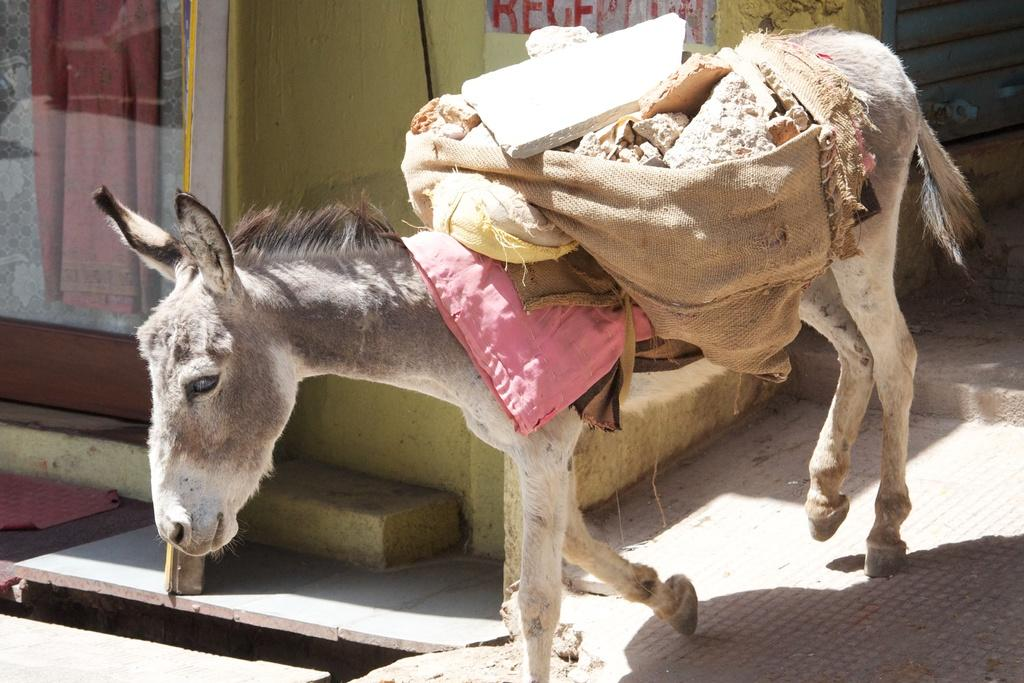What animal is present in the image? There is a donkey in the image. What is the donkey doing in the image? The donkey is walking. What can be seen on the left side of the image? There is a glass on the left side of the image. How long does it take for the donkey to eat a yam in the image? There is no yam present in the image, so it is not possible to determine how long it would take for the donkey to eat it. 